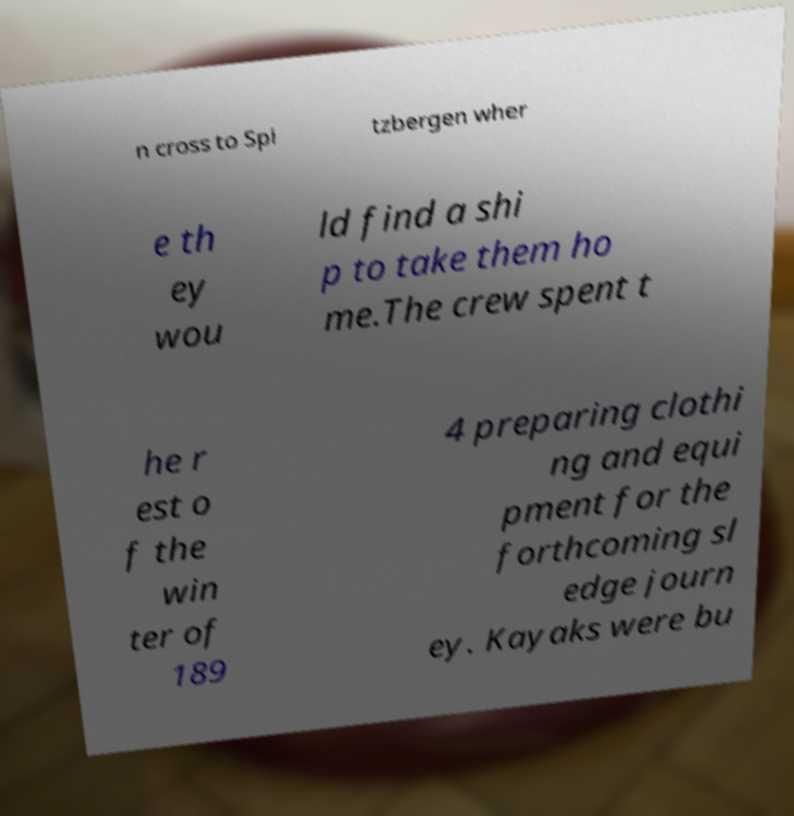For documentation purposes, I need the text within this image transcribed. Could you provide that? n cross to Spi tzbergen wher e th ey wou ld find a shi p to take them ho me.The crew spent t he r est o f the win ter of 189 4 preparing clothi ng and equi pment for the forthcoming sl edge journ ey. Kayaks were bu 